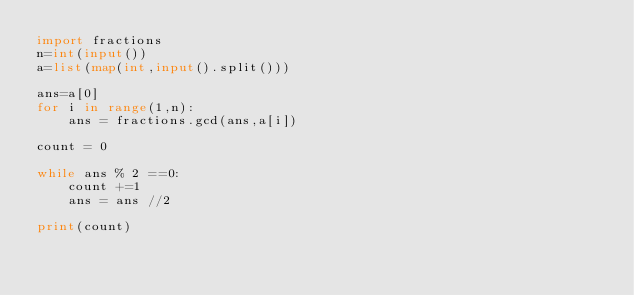Convert code to text. <code><loc_0><loc_0><loc_500><loc_500><_Python_>import fractions
n=int(input())
a=list(map(int,input().split()))

ans=a[0]
for i in range(1,n):
    ans = fractions.gcd(ans,a[i])

count = 0

while ans % 2 ==0:
    count +=1
    ans = ans //2
    
print(count)

</code> 